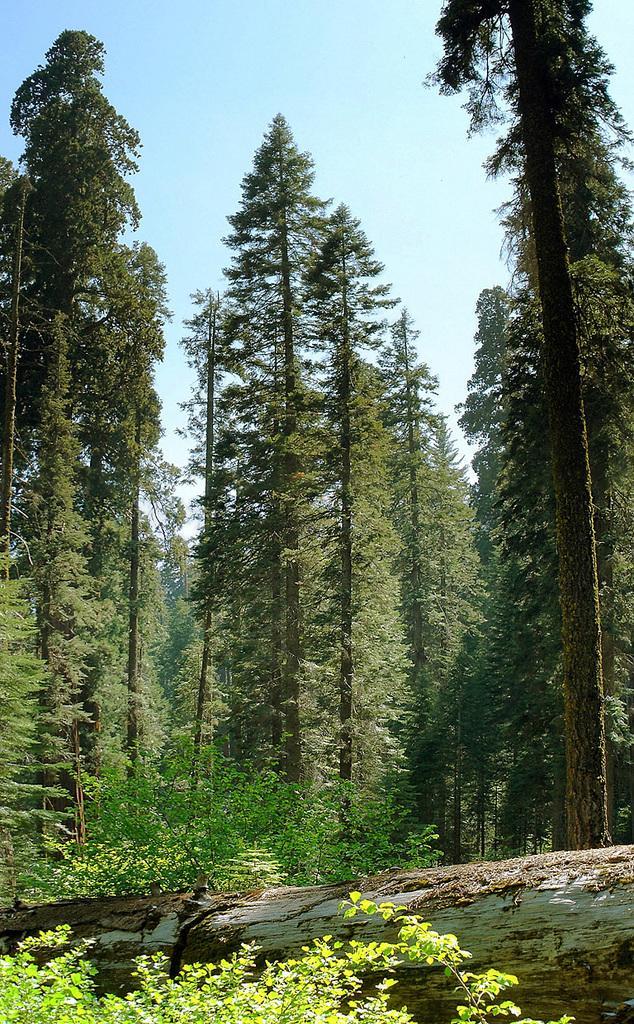Please provide a concise description of this image. In this picture, we can see trees, plants, fallen brand on the ground, and we can see the sky. 